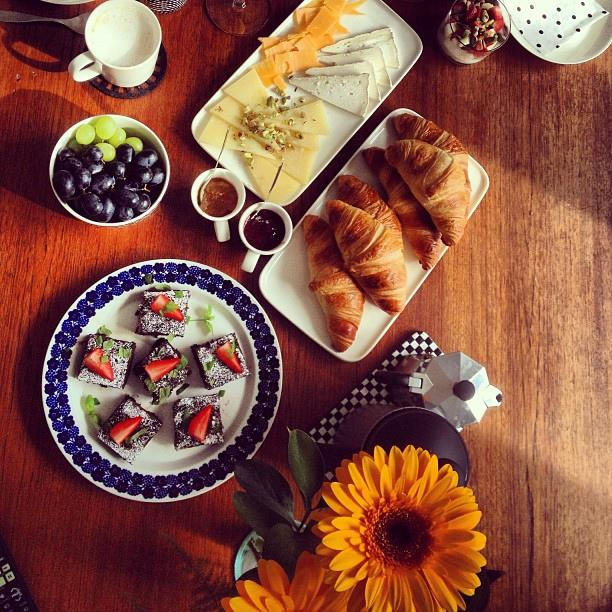Which people group invented the bread seen here?

Choices:
A) french
B) belgian
C) british
D) austrian austrian 